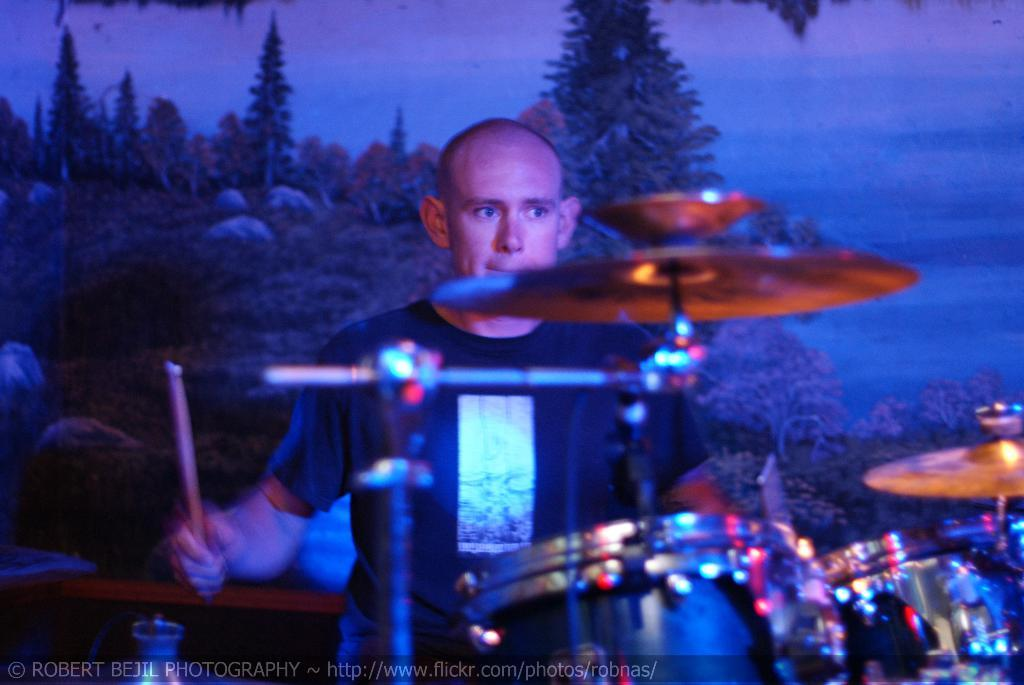What is the main subject of the image? The main subject of the image is a man. What is the man holding in the image? The man is holding drumsticks in the image. What musical instruments are in front of the man? There are drums and cymbals in front of the man. What is located behind the man in the image? There is a board behind the man. Can you describe any additional features of the image? The image has a watermark. How many quince are visible in the man's pocket in the image? There are no quince or pockets visible in the image; the man is holding drumsticks and standing in front of drums and cymbals. 